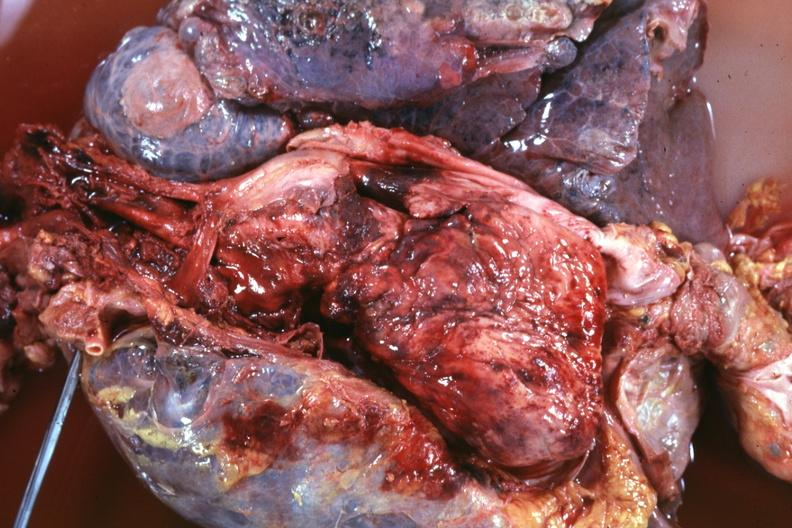does bone, skull show thoracic organs dissected to show super cava and region of tumor invasion quite good?
Answer the question using a single word or phrase. No 